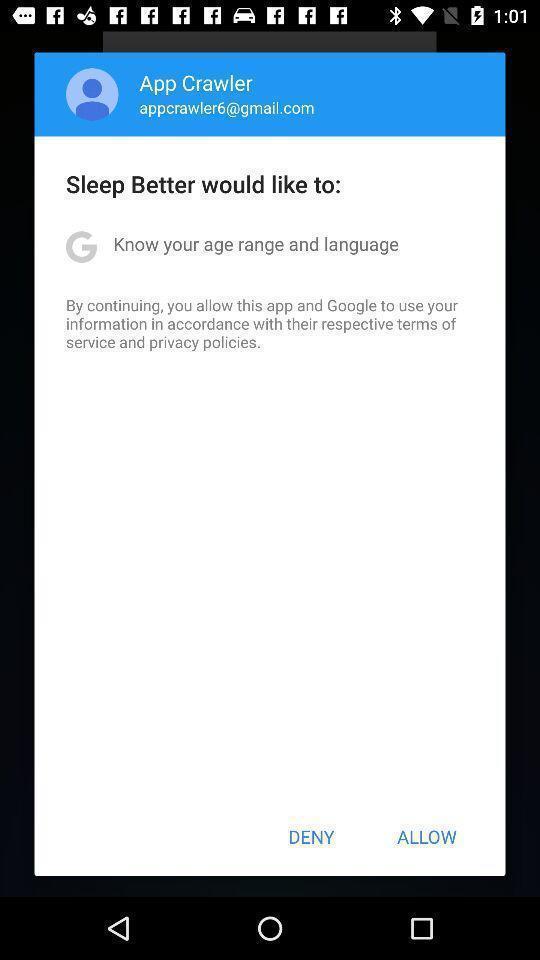Describe the key features of this screenshot. Popup showing deny and allow option. 